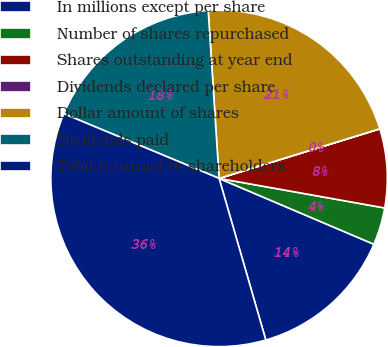<chart> <loc_0><loc_0><loc_500><loc_500><pie_chart><fcel>In millions except per share<fcel>Number of shares repurchased<fcel>Shares outstanding at year end<fcel>Dividends declared per share<fcel>Dollar amount of shares<fcel>Dividends paid<fcel>Total returned to shareholders<nl><fcel>14.12%<fcel>3.59%<fcel>7.57%<fcel>0.01%<fcel>21.26%<fcel>17.69%<fcel>35.76%<nl></chart> 